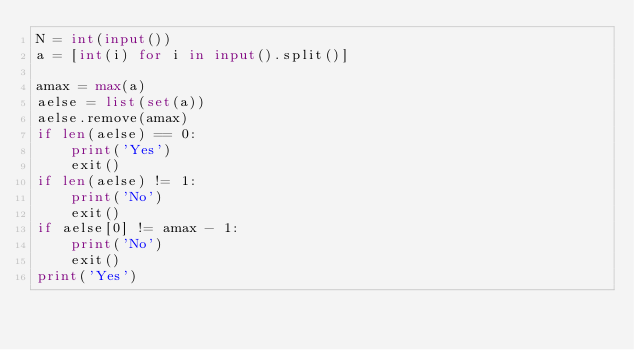<code> <loc_0><loc_0><loc_500><loc_500><_Python_>N = int(input())
a = [int(i) for i in input().split()]

amax = max(a)
aelse = list(set(a))
aelse.remove(amax)
if len(aelse) == 0:
    print('Yes')
    exit()
if len(aelse) != 1:
    print('No')
    exit()
if aelse[0] != amax - 1:
    print('No')
    exit()
print('Yes')</code> 